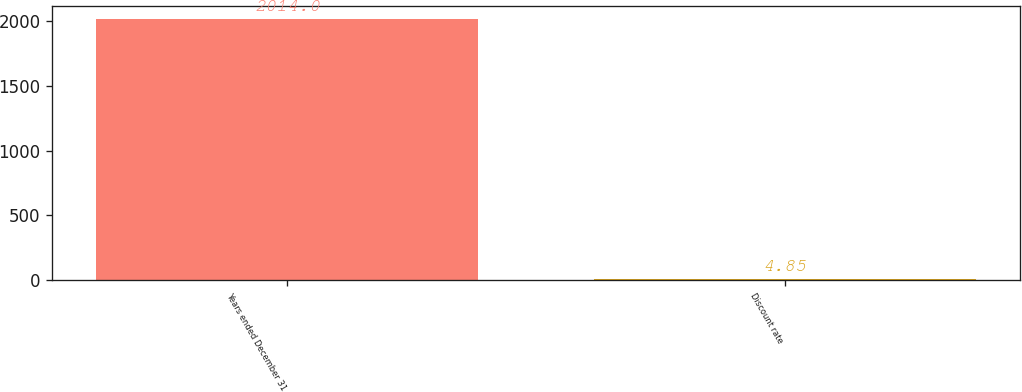Convert chart to OTSL. <chart><loc_0><loc_0><loc_500><loc_500><bar_chart><fcel>Years ended December 31<fcel>Discount rate<nl><fcel>2014<fcel>4.85<nl></chart> 